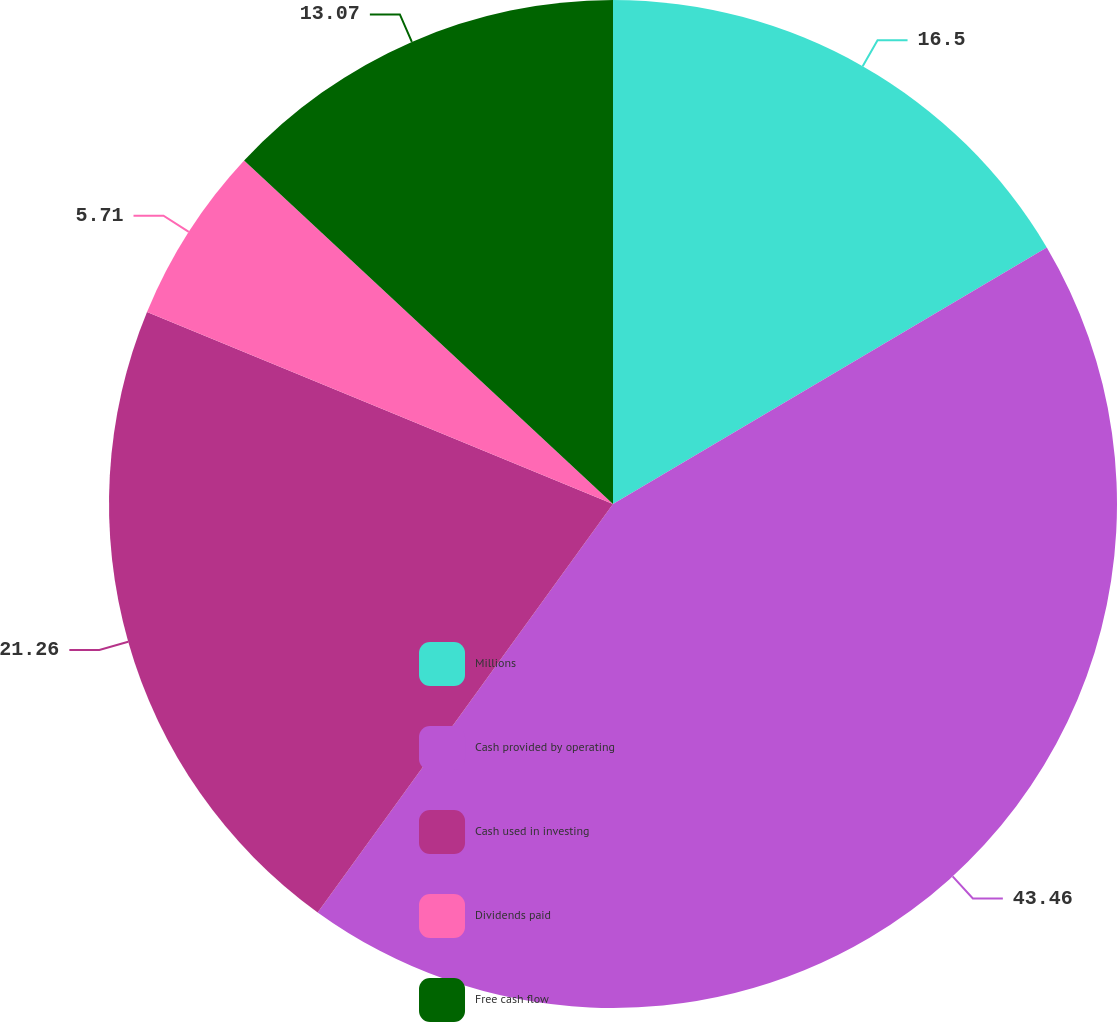Convert chart. <chart><loc_0><loc_0><loc_500><loc_500><pie_chart><fcel>Millions<fcel>Cash provided by operating<fcel>Cash used in investing<fcel>Dividends paid<fcel>Free cash flow<nl><fcel>16.5%<fcel>43.47%<fcel>21.26%<fcel>5.71%<fcel>13.07%<nl></chart> 